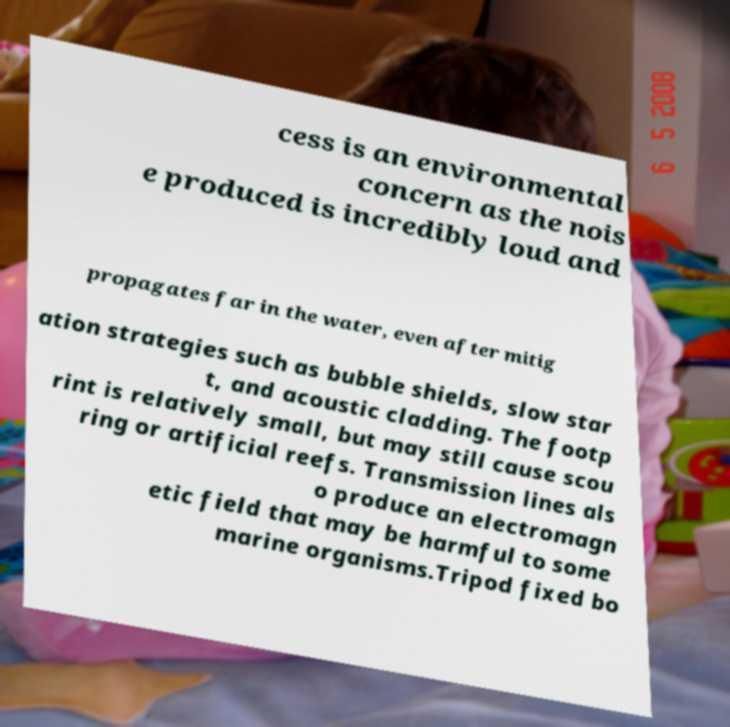Can you read and provide the text displayed in the image?This photo seems to have some interesting text. Can you extract and type it out for me? cess is an environmental concern as the nois e produced is incredibly loud and propagates far in the water, even after mitig ation strategies such as bubble shields, slow star t, and acoustic cladding. The footp rint is relatively small, but may still cause scou ring or artificial reefs. Transmission lines als o produce an electromagn etic field that may be harmful to some marine organisms.Tripod fixed bo 